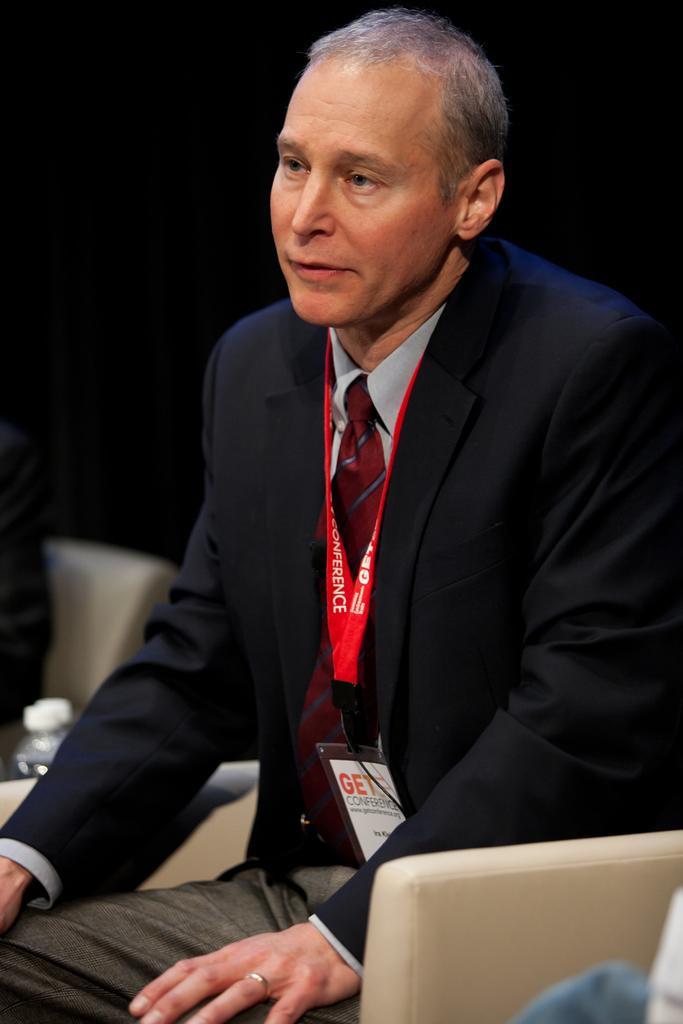What is the main subject of the image? There is a man in the image. What is the man doing in the image? The man is sitting on a chair. What year is depicted in the image? The image does not depict a specific year; it only shows a man sitting on a chair. What type of writing instrument is the man using in the image? There is no writing instrument present in the image, such as a quill. 